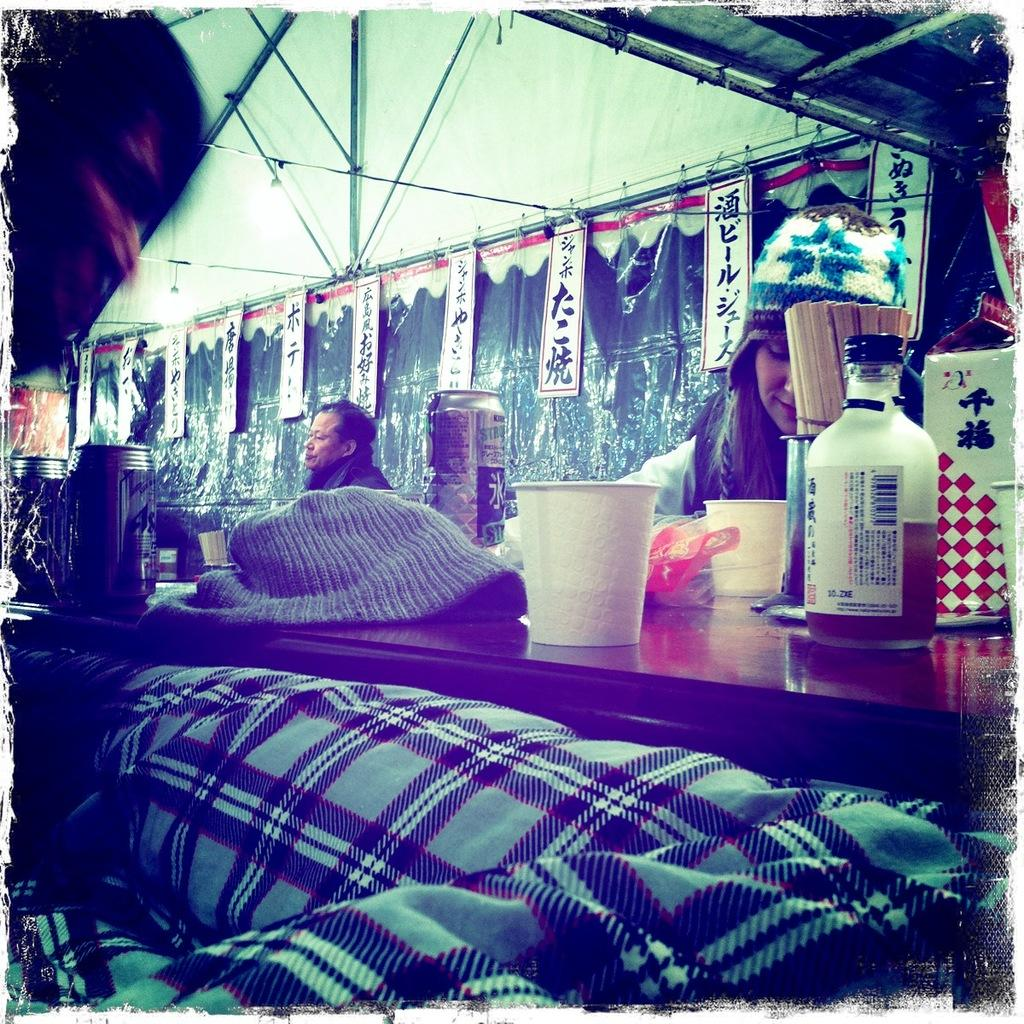What is the woman doing in the image? The woman is sitting on a chair in the image. What is in front of the woman? There is a table in front of the woman. What is on the table? There is a glass on the table, and there are other objects on the table as well. Who else is present in the image? There is a man sitting in the image. What type of care does the team provide in the image? There is no team or care mentioned in the image; it features a woman sitting on a chair and a man sitting, along with a table and objects. 